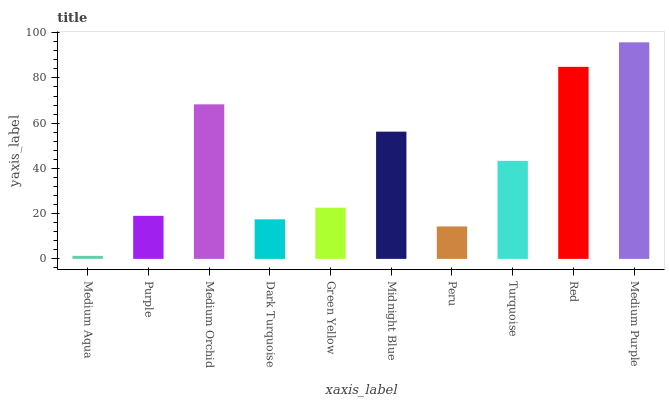Is Purple the minimum?
Answer yes or no. No. Is Purple the maximum?
Answer yes or no. No. Is Purple greater than Medium Aqua?
Answer yes or no. Yes. Is Medium Aqua less than Purple?
Answer yes or no. Yes. Is Medium Aqua greater than Purple?
Answer yes or no. No. Is Purple less than Medium Aqua?
Answer yes or no. No. Is Turquoise the high median?
Answer yes or no. Yes. Is Green Yellow the low median?
Answer yes or no. Yes. Is Medium Orchid the high median?
Answer yes or no. No. Is Medium Orchid the low median?
Answer yes or no. No. 